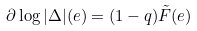<formula> <loc_0><loc_0><loc_500><loc_500>\partial \log | \Delta | ( e ) = ( 1 - q ) \tilde { F } ( e )</formula> 